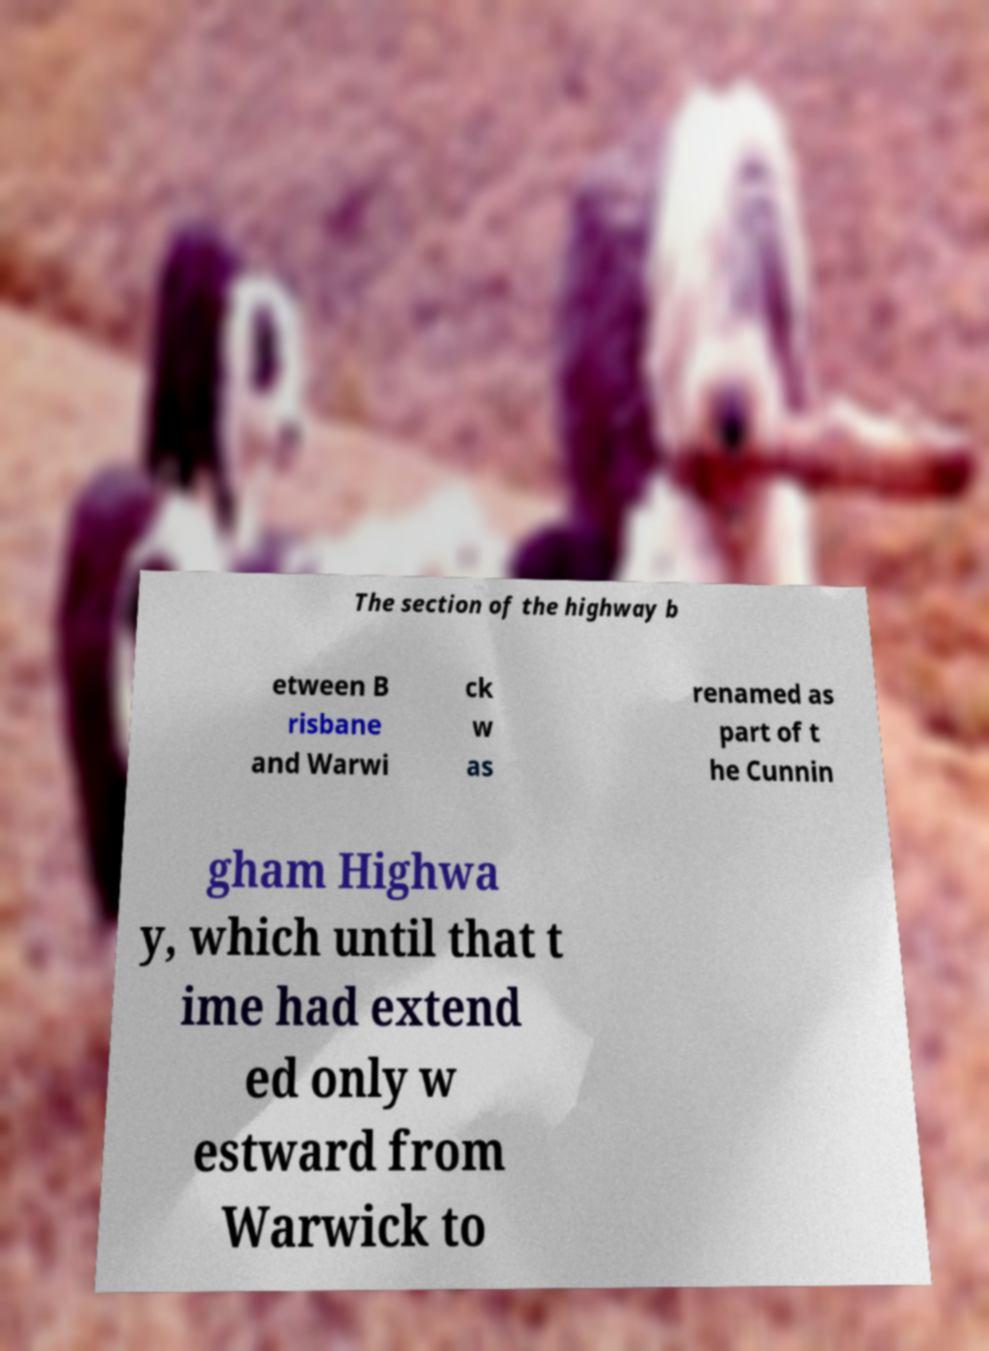Can you accurately transcribe the text from the provided image for me? The section of the highway b etween B risbane and Warwi ck w as renamed as part of t he Cunnin gham Highwa y, which until that t ime had extend ed only w estward from Warwick to 